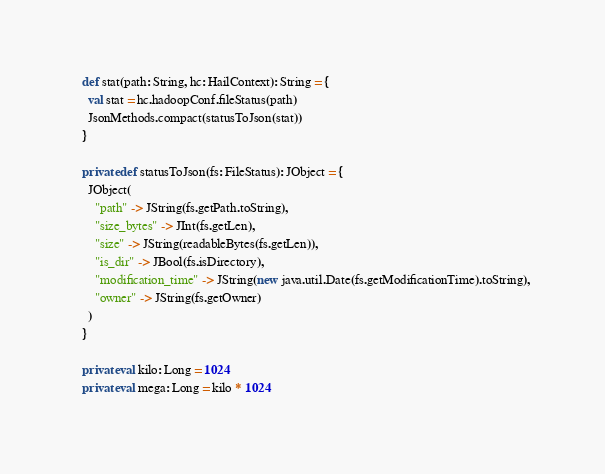Convert code to text. <code><loc_0><loc_0><loc_500><loc_500><_Scala_>
  def stat(path: String, hc: HailContext): String = {
    val stat = hc.hadoopConf.fileStatus(path)
    JsonMethods.compact(statusToJson(stat))
  }

  private def statusToJson(fs: FileStatus): JObject = {
    JObject(
      "path" -> JString(fs.getPath.toString),
      "size_bytes" -> JInt(fs.getLen),
      "size" -> JString(readableBytes(fs.getLen)),
      "is_dir" -> JBool(fs.isDirectory),
      "modification_time" -> JString(new java.util.Date(fs.getModificationTime).toString),
      "owner" -> JString(fs.getOwner)
    )
  }

  private val kilo: Long = 1024
  private val mega: Long = kilo * 1024</code> 